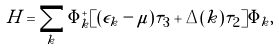Convert formula to latex. <formula><loc_0><loc_0><loc_500><loc_500>H = \sum _ { k } \Phi _ { k } ^ { + } [ ( \epsilon _ { k } - \mu ) \tau _ { 3 } + \Delta ( { k } ) \tau _ { 2 } ] \Phi _ { k } ,</formula> 